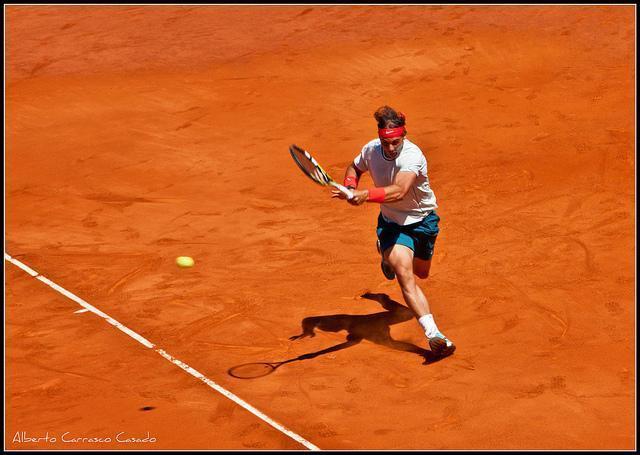How many people can you see?
Give a very brief answer. 1. How many zebras have all of their feet in the grass?
Give a very brief answer. 0. 